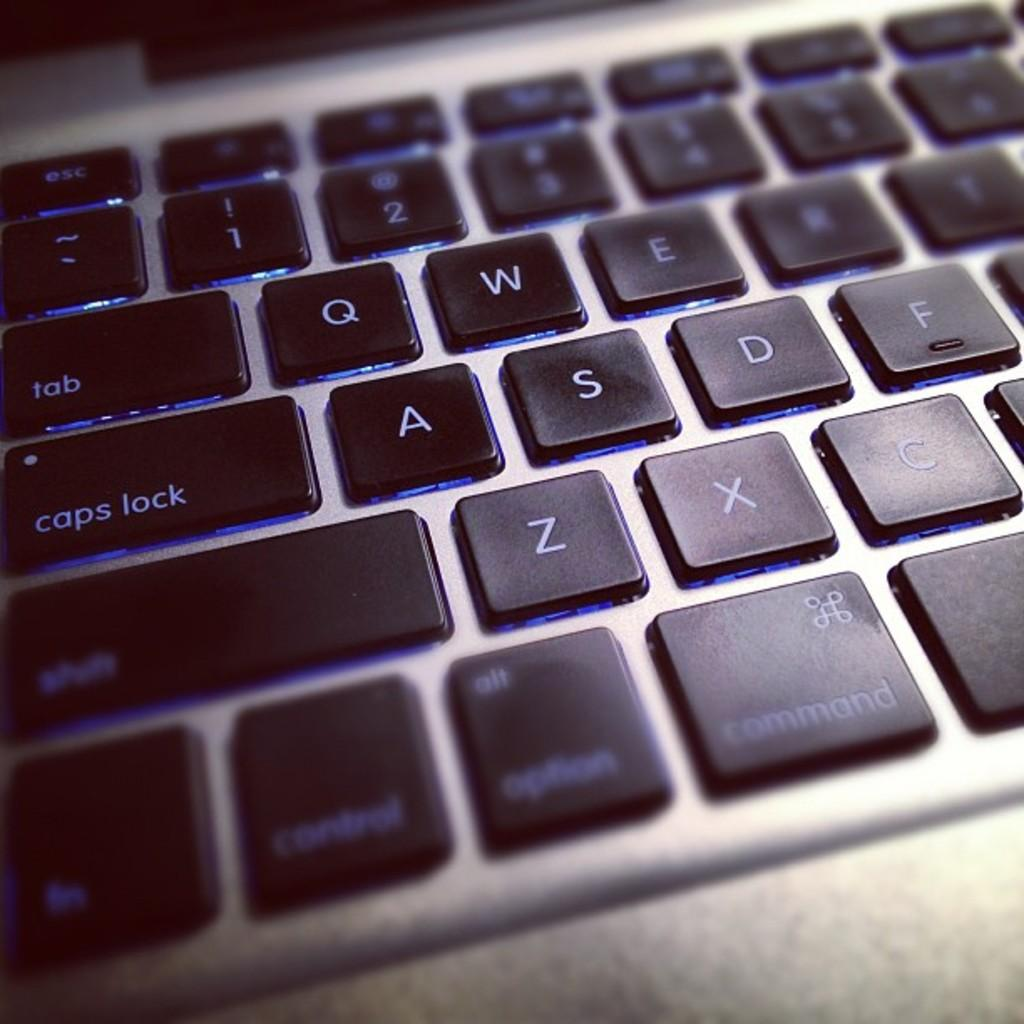<image>
Provide a brief description of the given image. A keyboard with many keys including tab, caps lock and shift. 